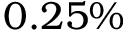Convert formula to latex. <formula><loc_0><loc_0><loc_500><loc_500>0 . 2 5 \%</formula> 